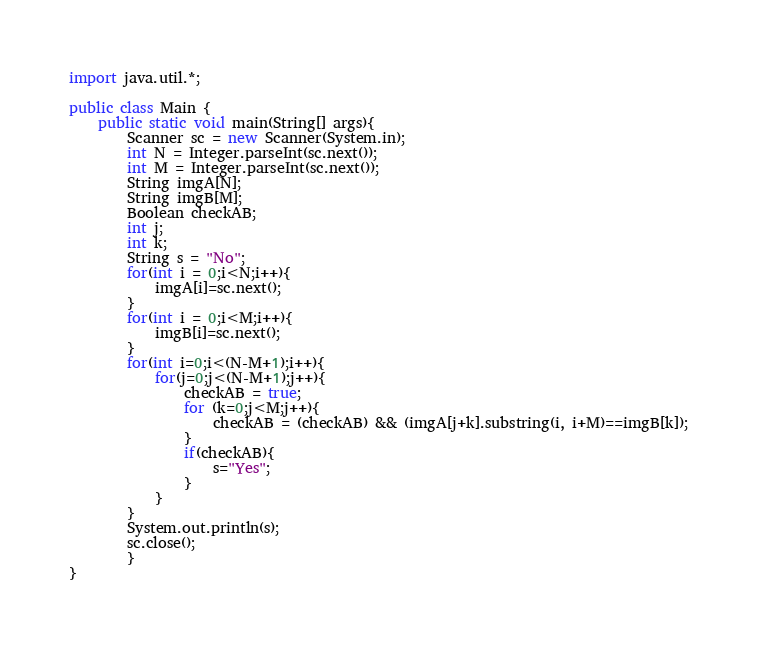Convert code to text. <code><loc_0><loc_0><loc_500><loc_500><_Java_>import java.util.*;

public class Main {
	public static void main(String[] args){
		Scanner sc = new Scanner(System.in);
		int N = Integer.parseInt(sc.next());
		int M = Integer.parseInt(sc.next());
		String imgA[N];
		String imgB[M];
		Boolean checkAB;
		int j;
		int k;
		String s = "No";
		for(int i = 0;i<N;i++){
			imgA[i]=sc.next();
		}
		for(int i = 0;i<M;i++){
			imgB[i]=sc.next();
		}
		for(int i=0;i<(N-M+1);i++){
			for(j=0;j<(N-M+1);j++){
				checkAB = true;
				for (k=0;j<M;j++){
					checkAB = (checkAB) && (imgA[j+k].substring(i, i+M)==imgB[k]);
				}
				if(checkAB){
					s="Yes";
				}
			}
		}
		System.out.println(s);
		sc.close();
        }
}</code> 